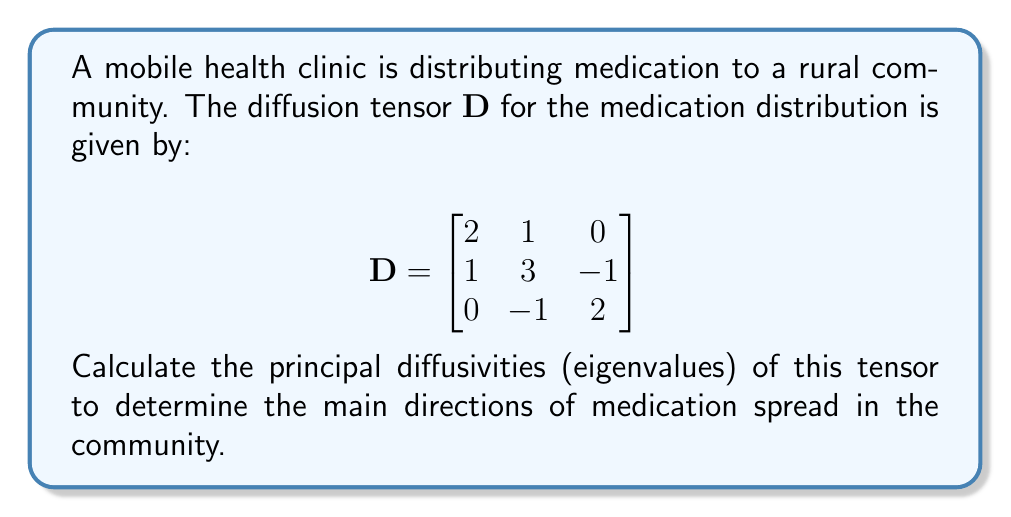Show me your answer to this math problem. To find the principal diffusivities, we need to calculate the eigenvalues of the diffusion tensor $\mathbf{D}$. 

Step 1: Set up the characteristic equation:
$$\det(\mathbf{D} - \lambda\mathbf{I}) = 0$$

Step 2: Expand the determinant:
$$\begin{vmatrix}
2-\lambda & 1 & 0 \\
1 & 3-\lambda & -1 \\
0 & -1 & 2-\lambda
\end{vmatrix} = 0$$

Step 3: Calculate the determinant:
$$(2-\lambda)[(3-\lambda)(2-\lambda) + 1] - 1[1(2-\lambda) + 0] = 0$$
$$(2-\lambda)[6-5\lambda+\lambda^2 + 1] - [2-\lambda] = 0$$
$$(2-\lambda)(7-5\lambda+\lambda^2) - (2-\lambda) = 0$$
$$14-10\lambda+2\lambda^2-7\lambda+5\lambda^2-\lambda^3 - 2 + \lambda = 0$$
$$-\lambda^3 + 7\lambda^2 - 16\lambda + 12 = 0$$

Step 4: Solve the cubic equation. The roots of this equation are the eigenvalues.
Using the cubic formula or a numerical method, we find the roots:

$\lambda_1 = 1$
$\lambda_2 = 2$
$\lambda_3 = 4$

These eigenvalues represent the principal diffusivities of the medication distribution in the community.
Answer: $\lambda_1 = 1, \lambda_2 = 2, \lambda_3 = 4$ 